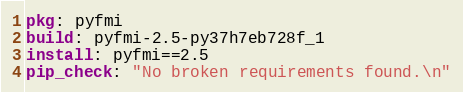<code> <loc_0><loc_0><loc_500><loc_500><_YAML_>pkg: pyfmi
build: pyfmi-2.5-py37h7eb728f_1
install: pyfmi==2.5
pip_check: "No broken requirements found.\n"
</code> 